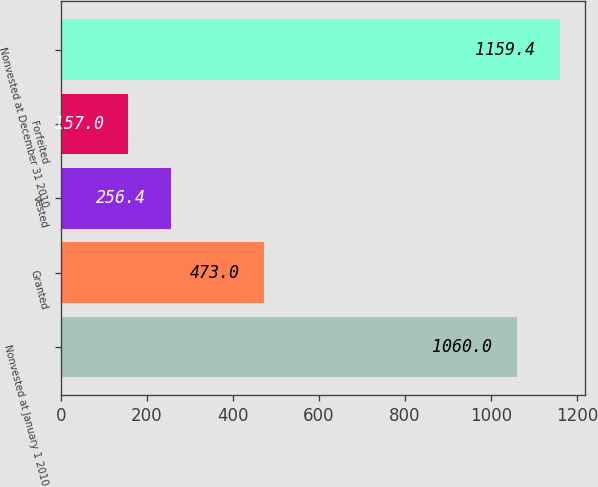Convert chart to OTSL. <chart><loc_0><loc_0><loc_500><loc_500><bar_chart><fcel>Nonvested at January 1 2010<fcel>Granted<fcel>Vested<fcel>Forfeited<fcel>Nonvested at December 31 2010<nl><fcel>1060<fcel>473<fcel>256.4<fcel>157<fcel>1159.4<nl></chart> 